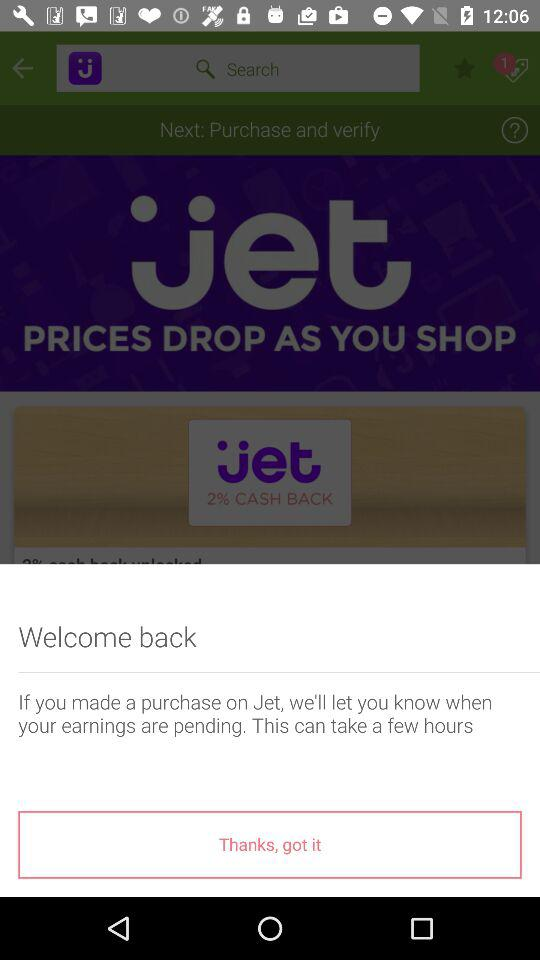What is the name of the application? The name of the application is "Jet". 